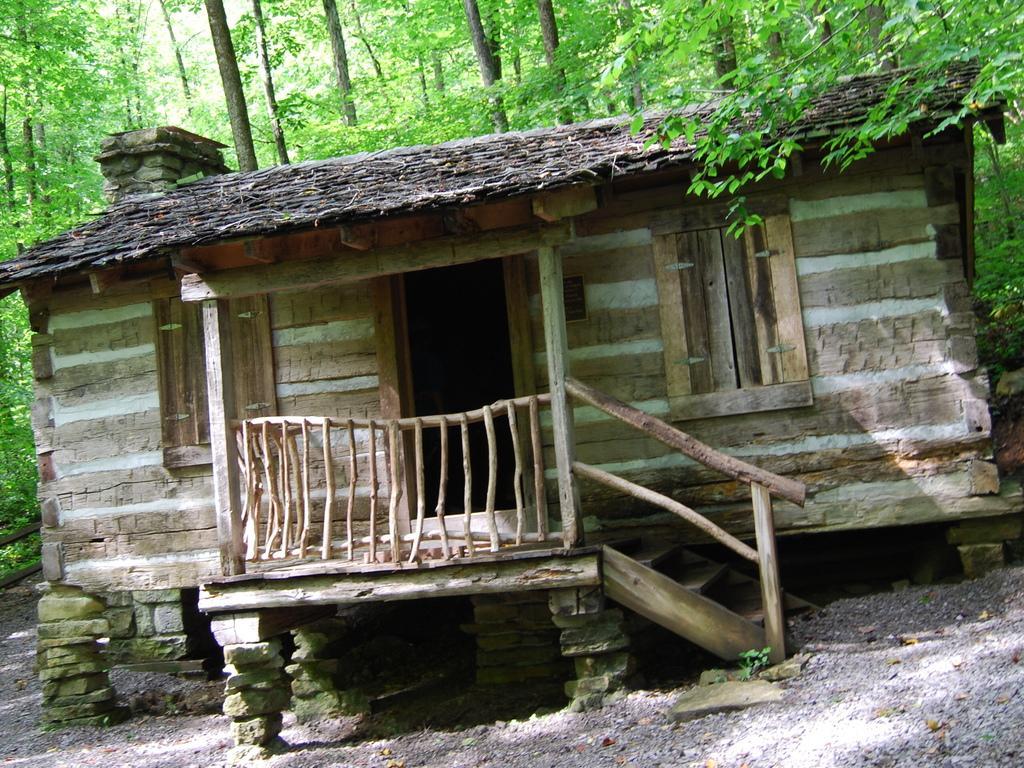Can you describe this image briefly? In this image we can see the wooden house. And we can see the windows and the door. And we can see the wooden railing and stairs. And we can see the trees. 